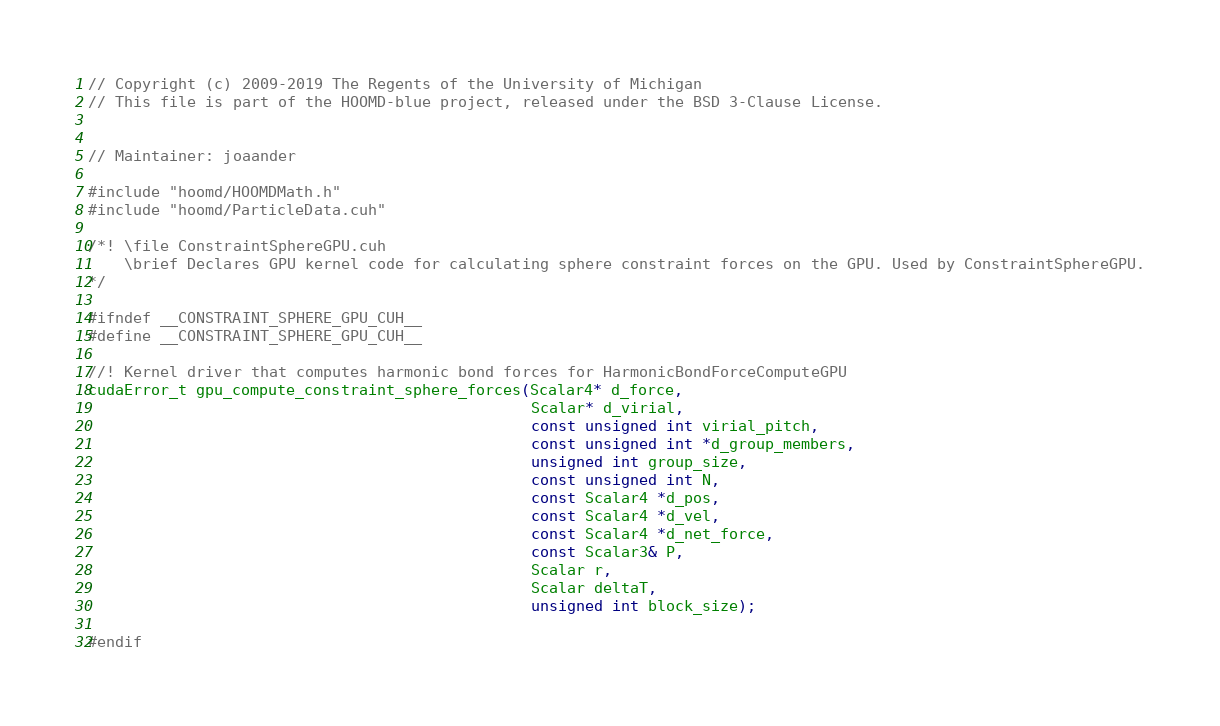<code> <loc_0><loc_0><loc_500><loc_500><_Cuda_>// Copyright (c) 2009-2019 The Regents of the University of Michigan
// This file is part of the HOOMD-blue project, released under the BSD 3-Clause License.


// Maintainer: joaander

#include "hoomd/HOOMDMath.h"
#include "hoomd/ParticleData.cuh"

/*! \file ConstraintSphereGPU.cuh
    \brief Declares GPU kernel code for calculating sphere constraint forces on the GPU. Used by ConstraintSphereGPU.
*/

#ifndef __CONSTRAINT_SPHERE_GPU_CUH__
#define __CONSTRAINT_SPHERE_GPU_CUH__

//! Kernel driver that computes harmonic bond forces for HarmonicBondForceComputeGPU
cudaError_t gpu_compute_constraint_sphere_forces(Scalar4* d_force,
                                                 Scalar* d_virial,
                                                 const unsigned int virial_pitch,
                                                 const unsigned int *d_group_members,
                                                 unsigned int group_size,
                                                 const unsigned int N,
                                                 const Scalar4 *d_pos,
                                                 const Scalar4 *d_vel,
                                                 const Scalar4 *d_net_force,
                                                 const Scalar3& P,
                                                 Scalar r,
                                                 Scalar deltaT,
                                                 unsigned int block_size);

#endif
</code> 